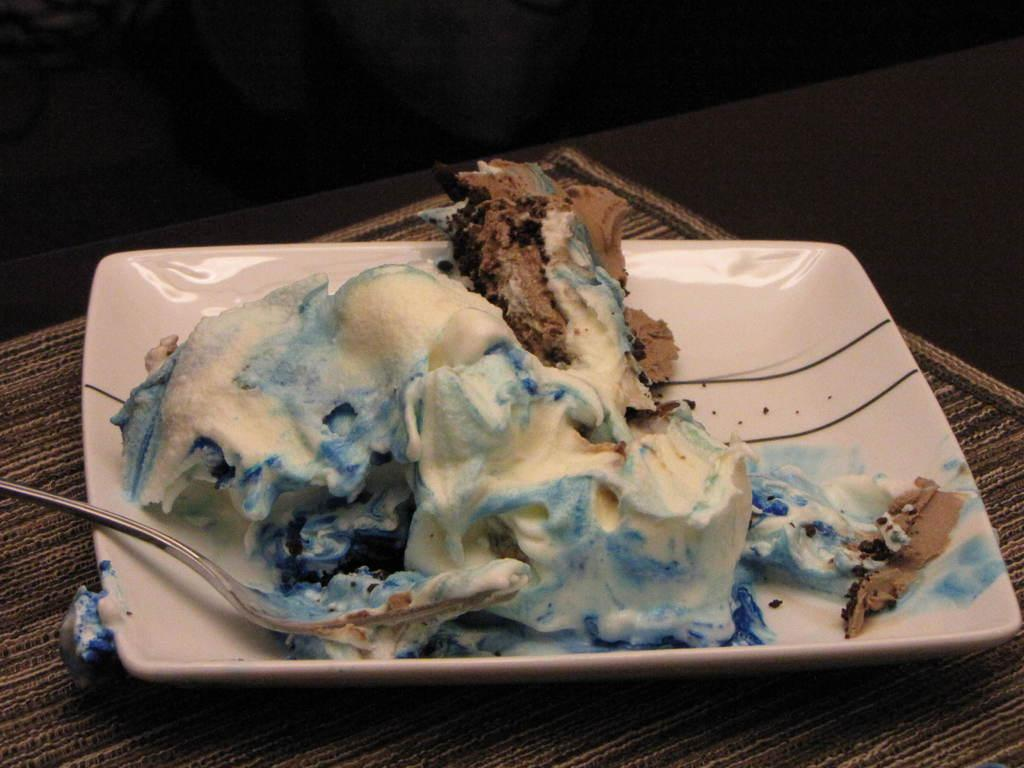What type of dessert is visible in the image? There is a pastry cake in the image. How is the pastry cake presented? The pastry cake is present on a plate. Where is the plate with the pastry cake located? The plate is on a table. What utensil is placed with the pastry cake? There is a spoon on the plate. What is the reaction of the pastry cake when it receives attention? The pastry cake does not have the ability to react, as it is an inanimate object. 